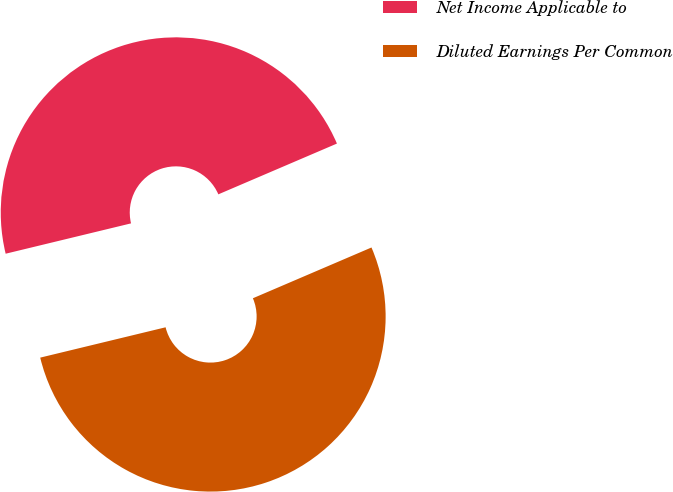Convert chart to OTSL. <chart><loc_0><loc_0><loc_500><loc_500><pie_chart><fcel>Net Income Applicable to<fcel>Diluted Earnings Per Common<nl><fcel>47.34%<fcel>52.66%<nl></chart> 